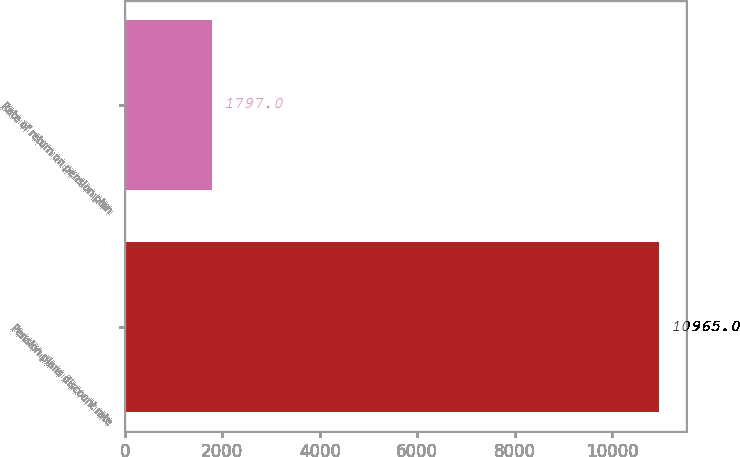<chart> <loc_0><loc_0><loc_500><loc_500><bar_chart><fcel>Pension plans discount rate<fcel>Rate of return on pension plan<nl><fcel>10965<fcel>1797<nl></chart> 